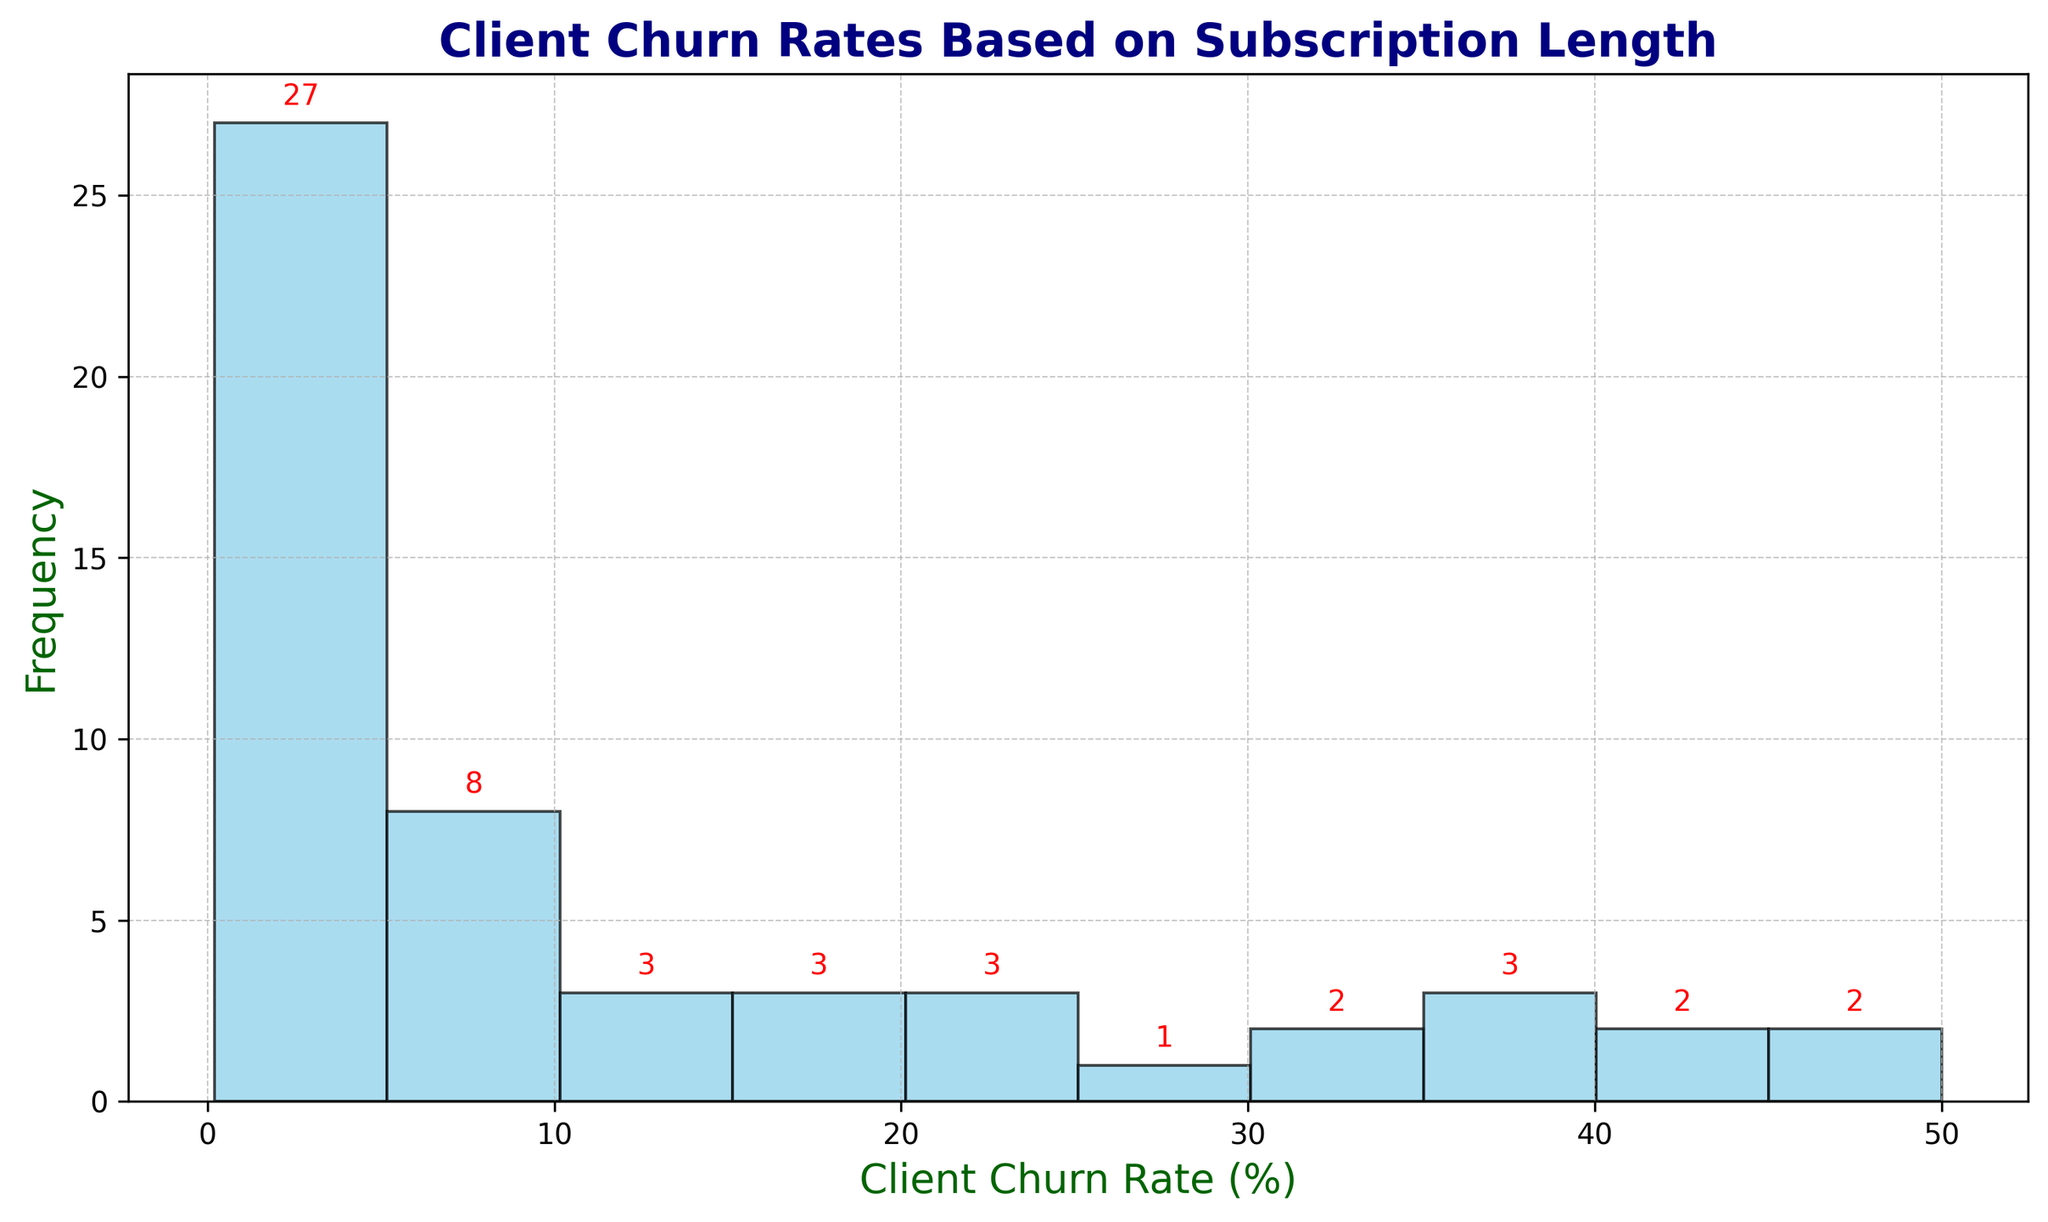What is the most common churn rate range? By looking at the histogram, identify the range where the highest number of clients fall. This can be identified by finding the tallest bar in the histogram.
Answer: 0-10% How many intervals show a non-zero churn rate? Count the number of bars in the histogram that have a height greater than zero.
Answer: 6 Which churn rate range has the highest frequency of clients? Identify the range with the tallest bar in the histogram, indicating the most common churn rate.
Answer: 0-10% Is the distribution of client churn rates skewed towards higher or lower churn rates? Analyze the histogram to observe whether the bars are taller (indicating more clients) at the lower or higher churn rate ranges.
Answer: Lower churn rates What is the frequency of clients with a churn rate in the range of 10-20%? Look at the bar corresponding to the 10-20% range and note the height of the bar, which represents how many clients fall into this range.
Answer: 6 How many clients have a churn rate of less than 5%? Examine the bars from 0-5% and sum the heights to find the total number of clients in this range.
Answer: 10 Which churn rate range shows the lowest frequency of clients? Identify the shortest bar in the histogram, indicating the least common churn rate range.
Answer: 40-50% What percentage of clients have a churn rate of 15% or less? Add the frequencies of all bins from 0-15% and divide by the total number of clients, then multiply by 100 to find the percentage.
Answer: 96% What is the range showing the median churn rate of clients? Median is the middle value. By adding up the frequencies from the lowest range until you reach the middle value of clients, you can find the range where the median falls.
Answer: 5-10% Which churn rate range has a frequency equal to the total frequency of the 30-40% and 40-50% ranges combined? Find the frequencies for the 30-40% and 40-50% ranges, sum them, and then identify the range with this total frequency.
Answer: 10-20% 